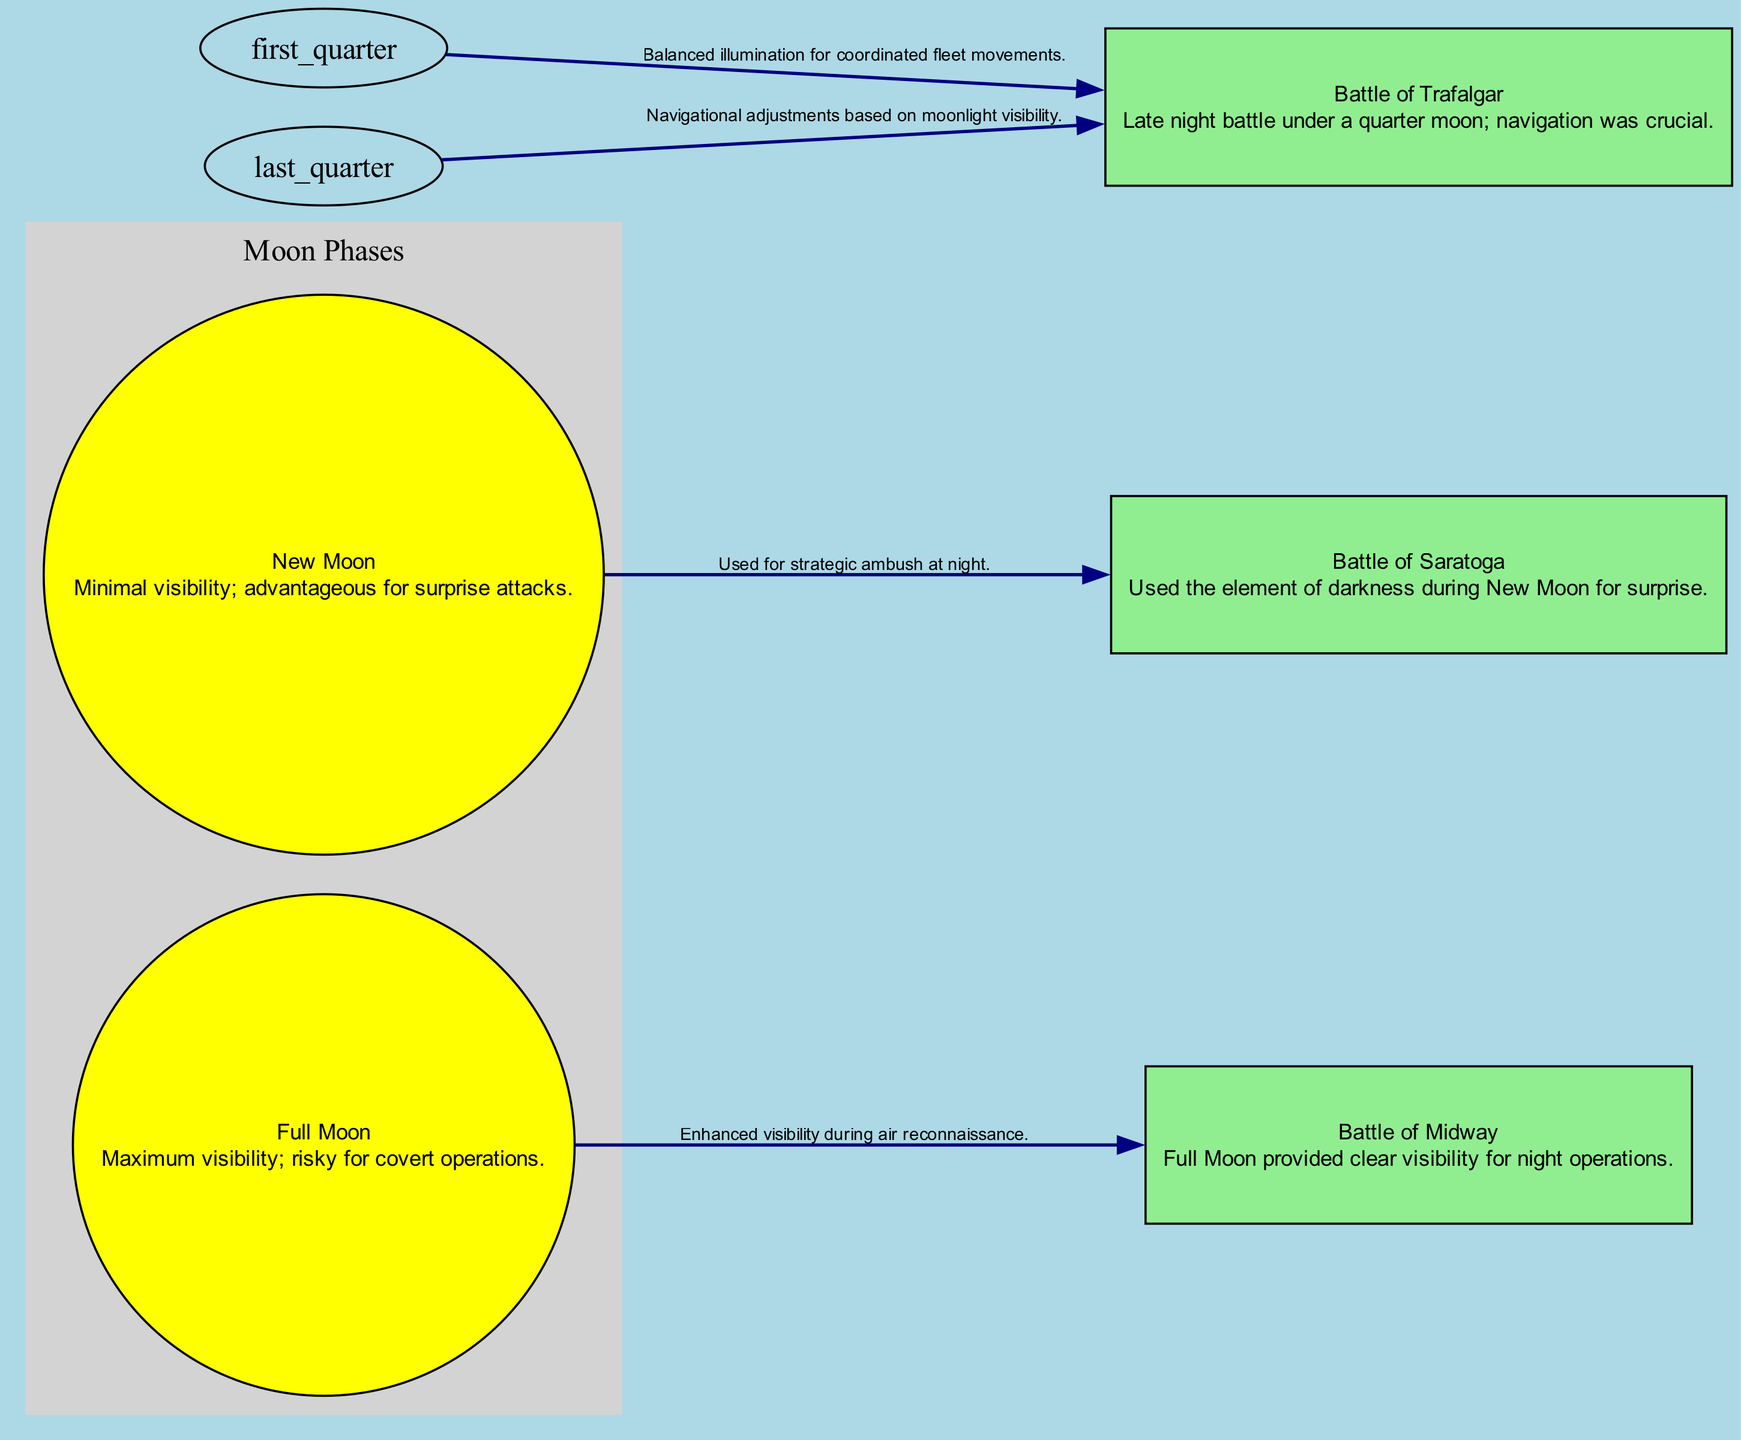What is the advantage of the New Moon phase? The New Moon phase is associated with minimal visibility, making it advantageous for surprise attacks during naval operations. This can be observed in the diagram where it connects to the Battle of Saratoga for its strategic use during darkness.
Answer: Minimal visibility; advantageous for surprise attacks Which battle utilized the Full Moon for operations? According to the diagram, the Full Moon provided maximum visibility, which was utilized in the Battle of Midway for air reconnaissance. This is illustrated as an edge connecting the Full Moon to this particular battle.
Answer: Battle of Midway How many nodes represent moon phases in the diagram? By examining the diagram, it can be seen that there are four nodes that represent the moon phases: New Moon, First Quarter Moon, Full Moon, and Last Quarter Moon.
Answer: Four What type of operations did the First Quarter Moon facilitate during the Battle of Trafalgar? The diagram indicates that the First Quarter Moon provided balanced illumination, which helped in coordinating fleet movements during the Battle of Trafalgar as shown by the connection between the First Quarter Moon and this battle.
Answer: Coordinated fleet movements Which battles are connected to the Last Quarter Moon, and why? The diagram shows that the Last Quarter Moon is connected to the Battle of Trafalgar, indicating that navigational adjustments were crucial due to moonlight visibility during the battle. This requires accessing both the Last Quarter Moon node and the Battle of Trafalgar node for your answer.
Answer: Battle of Trafalgar; navigational adjustments 